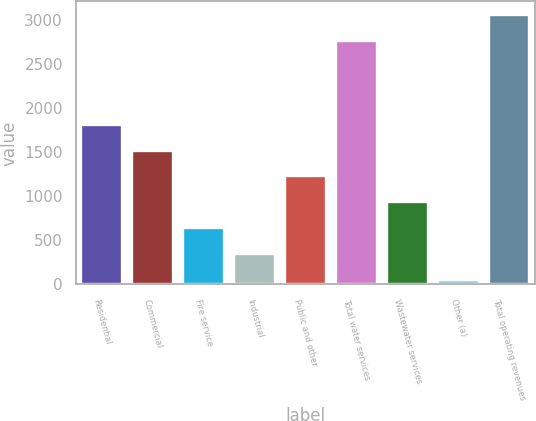Convert chart. <chart><loc_0><loc_0><loc_500><loc_500><bar_chart><fcel>Residential<fcel>Commercial<fcel>Fire service<fcel>Industrial<fcel>Public and other<fcel>Total water services<fcel>Wastewater services<fcel>Other (a)<fcel>Total operating revenues<nl><fcel>1812.4<fcel>1519.5<fcel>640.8<fcel>347.9<fcel>1226.6<fcel>2768<fcel>933.7<fcel>55<fcel>3060.9<nl></chart> 